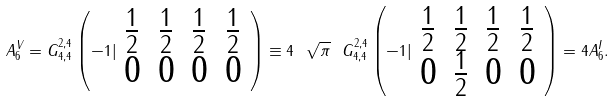<formula> <loc_0><loc_0><loc_500><loc_500>A _ { 6 } ^ { V } = G _ { 4 , 4 } ^ { 2 , 4 } \left ( - 1 | \begin{array} { l l l l } { \frac { 1 } { 2 } } & { \frac { 1 } { 2 } } & { \frac { 1 } { 2 } } & { \frac { 1 } { 2 } } \\ { 0 } & { 0 } & { 0 } & { 0 } \end{array} \right ) \equiv 4 \ { \sqrt { \pi } } \ G _ { 4 , 4 } ^ { 2 , 4 } \left ( - 1 | \begin{array} { l l l l } { \frac { 1 } { 2 } } & { \frac { 1 } { 2 } } & { \frac { 1 } { 2 } } & { \frac { 1 } { 2 } } \\ { 0 } & { \frac { 1 } { 2 } } & { 0 } & { 0 } \end{array} \right ) = 4 A _ { 6 } ^ { I } .</formula> 